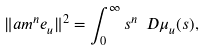Convert formula to latex. <formula><loc_0><loc_0><loc_500><loc_500>\| \sl a m ^ { n } e _ { u } \| ^ { 2 } = \int _ { 0 } ^ { \infty } s ^ { n } \ D \mu _ { u } ( s ) ,</formula> 